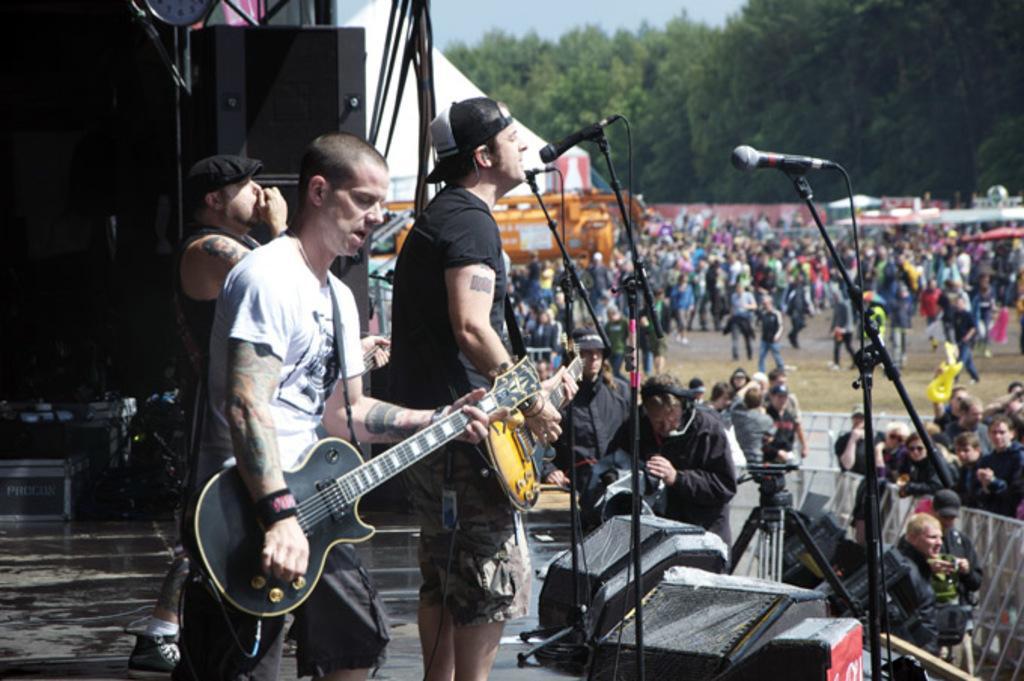Describe this image in one or two sentences. In this picture we can see three men on stage where two are holding guitars in their hands and playing it and one is singing on mic and in front of them a group of people where some are standing and some are walking and we have fence, camera stand, tree, sky, speakers, clock. 